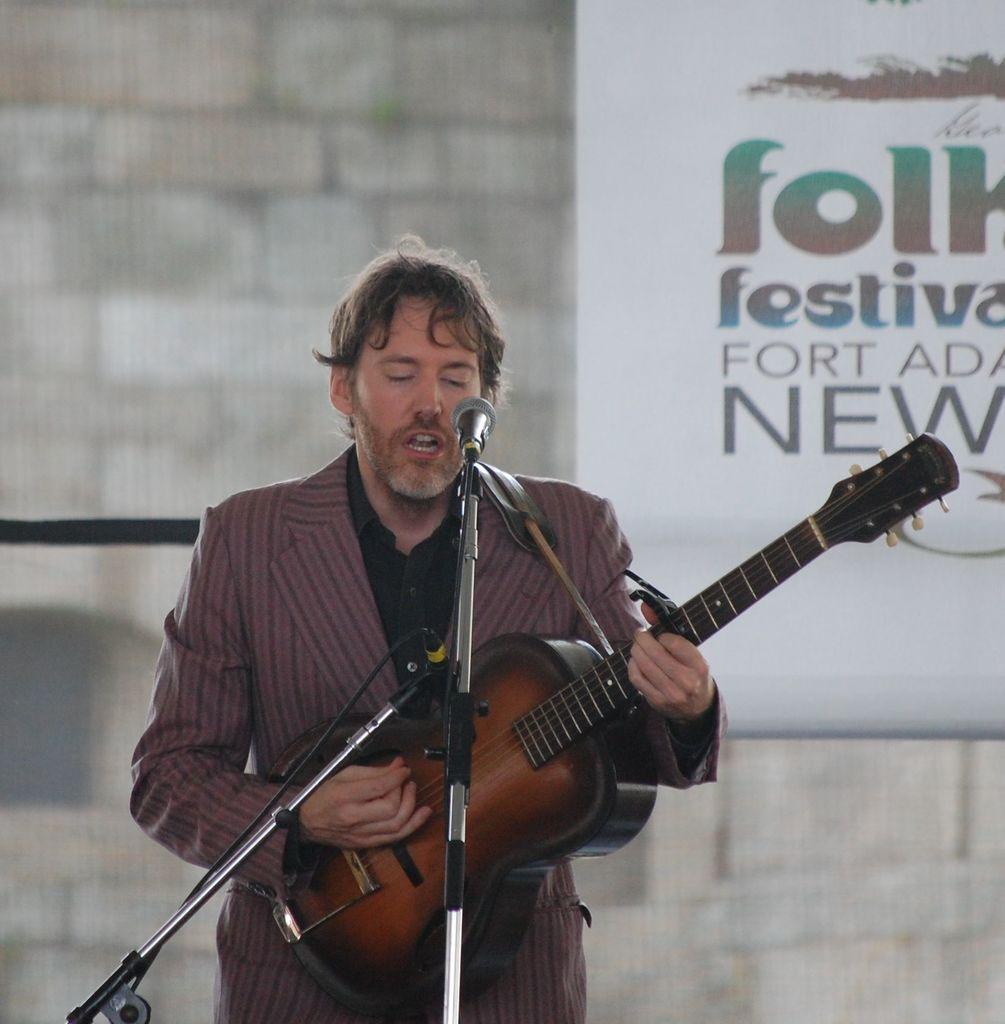Please provide a concise description of this image. In this picture we can see that a person is standing on the floor and he is wearing a suit and he is singing, and holding a guitar in his hands and in front here is the microphone and stand, and at back here is the wall, and something written on it. 